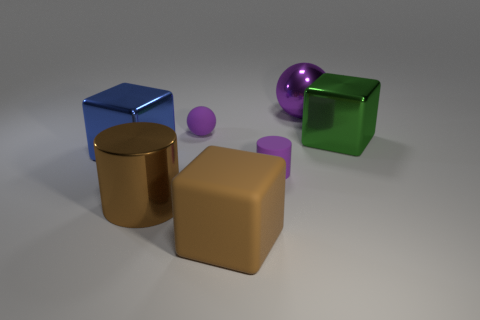There is another rubber object that is the same shape as the big blue object; what color is it?
Ensure brevity in your answer.  Brown. What material is the large blue block?
Offer a terse response. Metal. What number of other objects are the same size as the shiny cylinder?
Keep it short and to the point. 4. What size is the cylinder that is behind the big brown metallic cylinder?
Make the answer very short. Small. What is the purple sphere that is on the left side of the large object behind the large block that is to the right of the purple metal ball made of?
Your response must be concise. Rubber. Does the purple metal thing have the same shape as the large rubber object?
Give a very brief answer. No. How many metal objects are either big red things or large blocks?
Ensure brevity in your answer.  2. How many green metallic blocks are there?
Offer a very short reply. 1. What is the color of the metallic cylinder that is the same size as the shiny ball?
Give a very brief answer. Brown. Do the purple metallic thing and the blue cube have the same size?
Keep it short and to the point. Yes. 